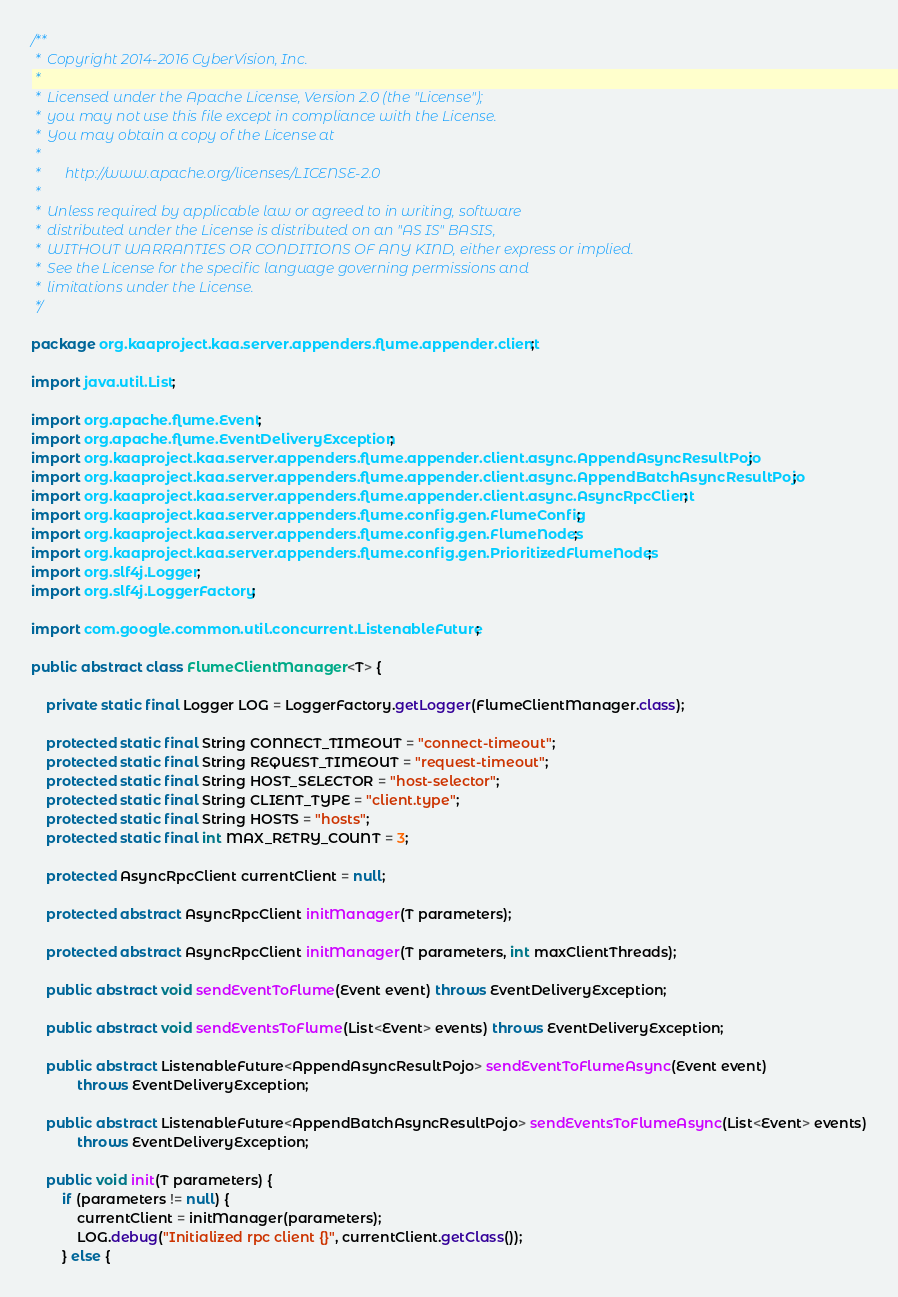Convert code to text. <code><loc_0><loc_0><loc_500><loc_500><_Java_>/**
 *  Copyright 2014-2016 CyberVision, Inc.
 *
 *  Licensed under the Apache License, Version 2.0 (the "License");
 *  you may not use this file except in compliance with the License.
 *  You may obtain a copy of the License at
 *
 *       http://www.apache.org/licenses/LICENSE-2.0
 *
 *  Unless required by applicable law or agreed to in writing, software
 *  distributed under the License is distributed on an "AS IS" BASIS,
 *  WITHOUT WARRANTIES OR CONDITIONS OF ANY KIND, either express or implied.
 *  See the License for the specific language governing permissions and
 *  limitations under the License.
 */

package org.kaaproject.kaa.server.appenders.flume.appender.client;

import java.util.List;

import org.apache.flume.Event;
import org.apache.flume.EventDeliveryException;
import org.kaaproject.kaa.server.appenders.flume.appender.client.async.AppendAsyncResultPojo;
import org.kaaproject.kaa.server.appenders.flume.appender.client.async.AppendBatchAsyncResultPojo;
import org.kaaproject.kaa.server.appenders.flume.appender.client.async.AsyncRpcClient;
import org.kaaproject.kaa.server.appenders.flume.config.gen.FlumeConfig;
import org.kaaproject.kaa.server.appenders.flume.config.gen.FlumeNodes;
import org.kaaproject.kaa.server.appenders.flume.config.gen.PrioritizedFlumeNodes;
import org.slf4j.Logger;
import org.slf4j.LoggerFactory;

import com.google.common.util.concurrent.ListenableFuture;

public abstract class FlumeClientManager<T> {

    private static final Logger LOG = LoggerFactory.getLogger(FlumeClientManager.class);

    protected static final String CONNECT_TIMEOUT = "connect-timeout";
    protected static final String REQUEST_TIMEOUT = "request-timeout";
    protected static final String HOST_SELECTOR = "host-selector";
    protected static final String CLIENT_TYPE = "client.type";
    protected static final String HOSTS = "hosts";
    protected static final int MAX_RETRY_COUNT = 3;

    protected AsyncRpcClient currentClient = null;

    protected abstract AsyncRpcClient initManager(T parameters);

    protected abstract AsyncRpcClient initManager(T parameters, int maxClientThreads);

    public abstract void sendEventToFlume(Event event) throws EventDeliveryException;

    public abstract void sendEventsToFlume(List<Event> events) throws EventDeliveryException;

    public abstract ListenableFuture<AppendAsyncResultPojo> sendEventToFlumeAsync(Event event)
            throws EventDeliveryException;

    public abstract ListenableFuture<AppendBatchAsyncResultPojo> sendEventsToFlumeAsync(List<Event> events)
            throws EventDeliveryException;

    public void init(T parameters) {
        if (parameters != null) {
            currentClient = initManager(parameters);
            LOG.debug("Initialized rpc client {}", currentClient.getClass());
        } else {</code> 